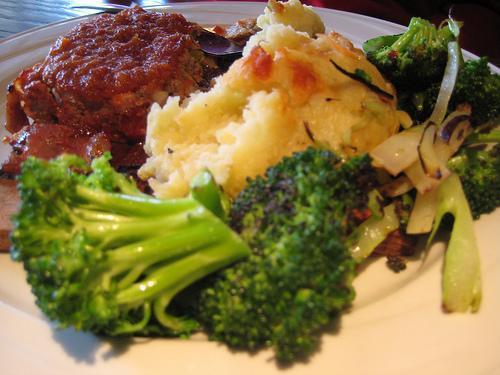How many plates are there?
Give a very brief answer. 1. How many servings of meatloaf are there?
Give a very brief answer. 1. How many people are shown?
Give a very brief answer. 0. How many people are eating food?
Give a very brief answer. 0. 